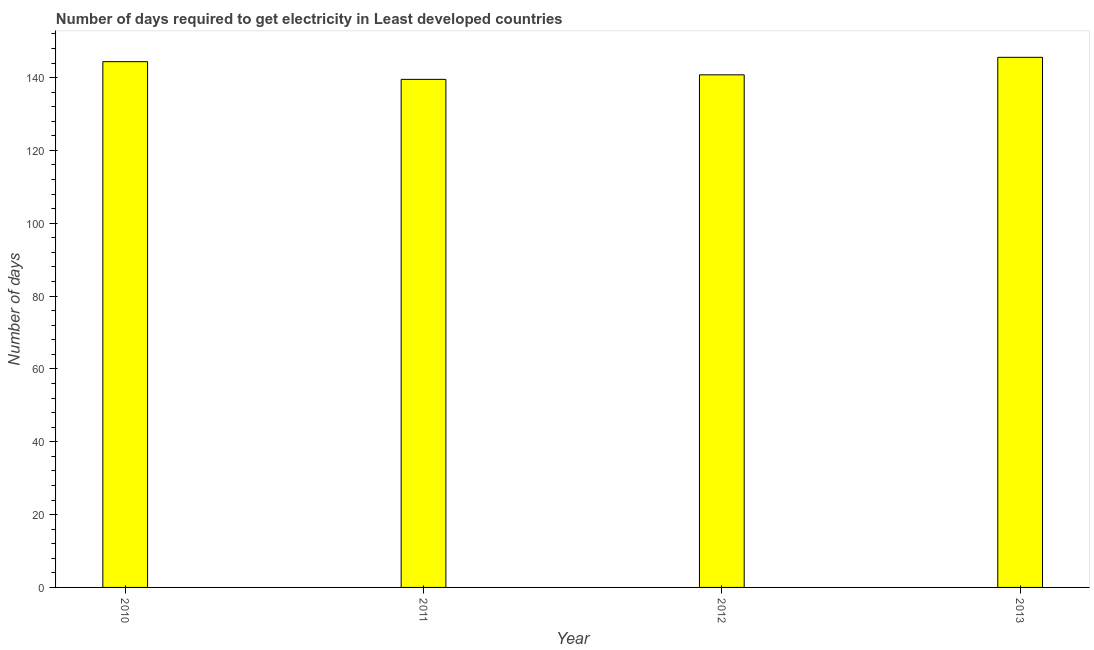Does the graph contain any zero values?
Provide a succinct answer. No. What is the title of the graph?
Offer a terse response. Number of days required to get electricity in Least developed countries. What is the label or title of the Y-axis?
Your answer should be very brief. Number of days. What is the time to get electricity in 2011?
Offer a very short reply. 139.51. Across all years, what is the maximum time to get electricity?
Your response must be concise. 145.56. Across all years, what is the minimum time to get electricity?
Your response must be concise. 139.51. In which year was the time to get electricity maximum?
Give a very brief answer. 2013. In which year was the time to get electricity minimum?
Your response must be concise. 2011. What is the sum of the time to get electricity?
Offer a very short reply. 570.2. What is the difference between the time to get electricity in 2010 and 2012?
Give a very brief answer. 3.62. What is the average time to get electricity per year?
Your response must be concise. 142.55. What is the median time to get electricity?
Keep it short and to the point. 142.56. Do a majority of the years between 2013 and 2012 (inclusive) have time to get electricity greater than 140 ?
Offer a terse response. No. What is the ratio of the time to get electricity in 2010 to that in 2011?
Ensure brevity in your answer.  1.03. What is the difference between the highest and the second highest time to get electricity?
Your answer should be very brief. 1.19. What is the difference between the highest and the lowest time to get electricity?
Keep it short and to the point. 6.05. Are all the bars in the graph horizontal?
Provide a succinct answer. No. How many years are there in the graph?
Ensure brevity in your answer.  4. What is the Number of days in 2010?
Provide a short and direct response. 144.37. What is the Number of days in 2011?
Your answer should be very brief. 139.51. What is the Number of days of 2012?
Your response must be concise. 140.76. What is the Number of days of 2013?
Provide a short and direct response. 145.56. What is the difference between the Number of days in 2010 and 2011?
Give a very brief answer. 4.86. What is the difference between the Number of days in 2010 and 2012?
Give a very brief answer. 3.62. What is the difference between the Number of days in 2010 and 2013?
Provide a short and direct response. -1.19. What is the difference between the Number of days in 2011 and 2012?
Provide a short and direct response. -1.24. What is the difference between the Number of days in 2011 and 2013?
Your answer should be compact. -6.05. What is the difference between the Number of days in 2012 and 2013?
Your answer should be compact. -4.81. What is the ratio of the Number of days in 2010 to that in 2011?
Your answer should be compact. 1.03. What is the ratio of the Number of days in 2010 to that in 2012?
Make the answer very short. 1.03. What is the ratio of the Number of days in 2010 to that in 2013?
Your answer should be compact. 0.99. What is the ratio of the Number of days in 2011 to that in 2012?
Offer a terse response. 0.99. What is the ratio of the Number of days in 2011 to that in 2013?
Your answer should be compact. 0.96. 